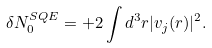<formula> <loc_0><loc_0><loc_500><loc_500>\delta N ^ { S Q E } _ { 0 } = + 2 \int d ^ { 3 } { r } | v _ { j } ( { r } ) | ^ { 2 } .</formula> 